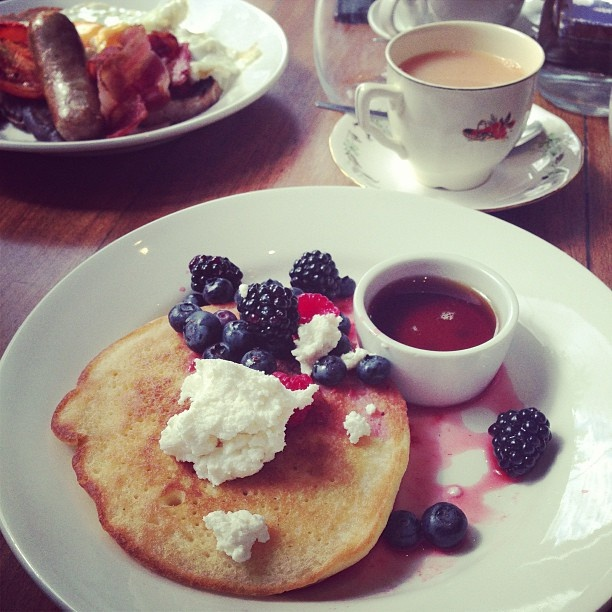Describe the objects in this image and their specific colors. I can see dining table in darkgray, beige, black, and brown tones, cup in black, darkgray, beige, tan, and gray tones, cup in black, purple, darkgray, and beige tones, bowl in black, purple, darkgray, and beige tones, and dining table in black, purple, and brown tones in this image. 